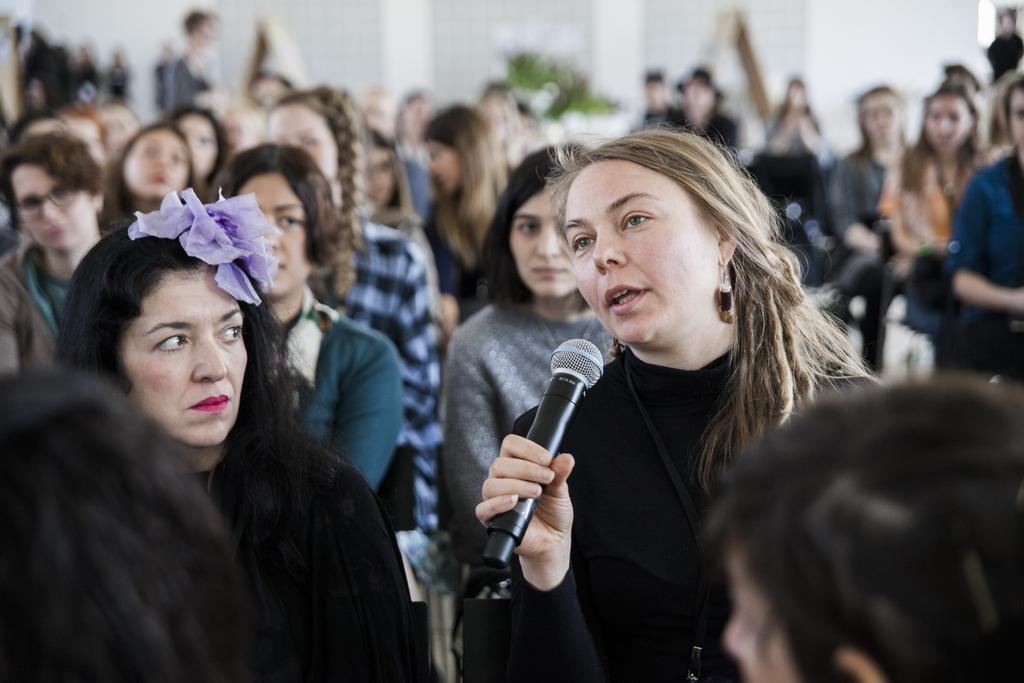What can be seen in the image? There is a group of audience and a lady in the image. What is the lady holding in the image? The lady is holding a mic in the image. Where is the lady positioned in the image? The lady is at the right side of the image. What might the lady be doing in the image? The lady appears to be asking a question in the image. What language is the lady speaking in the image? The provided facts do not mention the language being spoken in the image. Is the lady standing in quicksand in the image? There is no indication of quicksand in the image; the lady is standing on a surface that appears to be solid. 